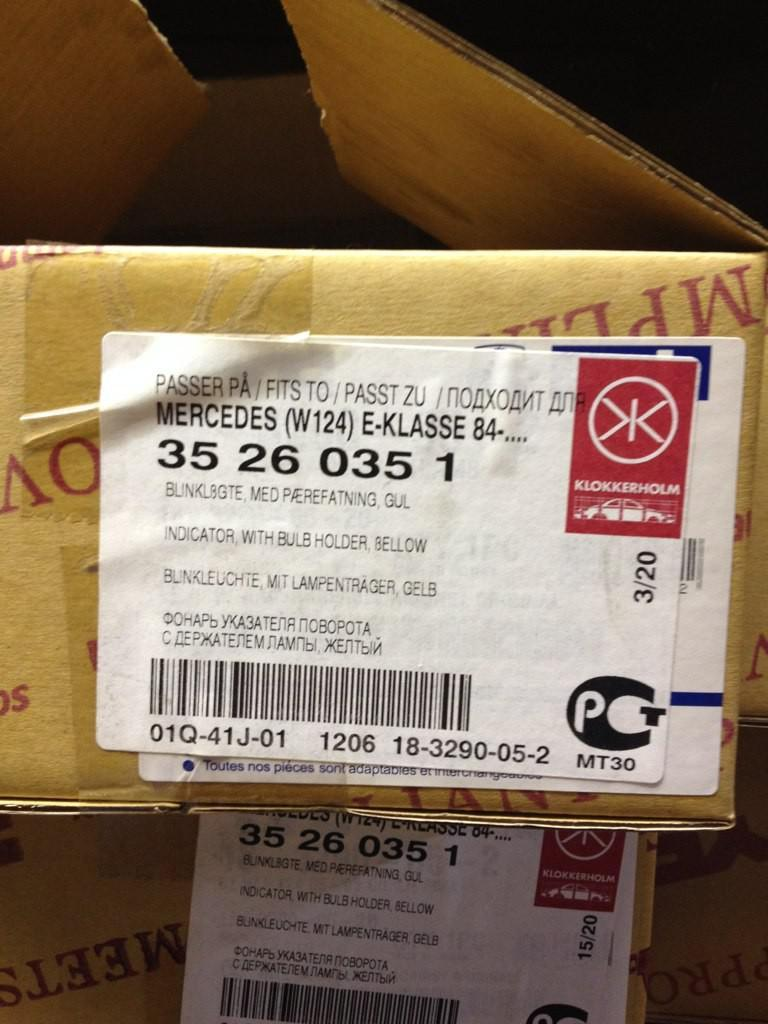<image>
Share a concise interpretation of the image provided. A package that has a label on top, the label says Mercedes on it. 